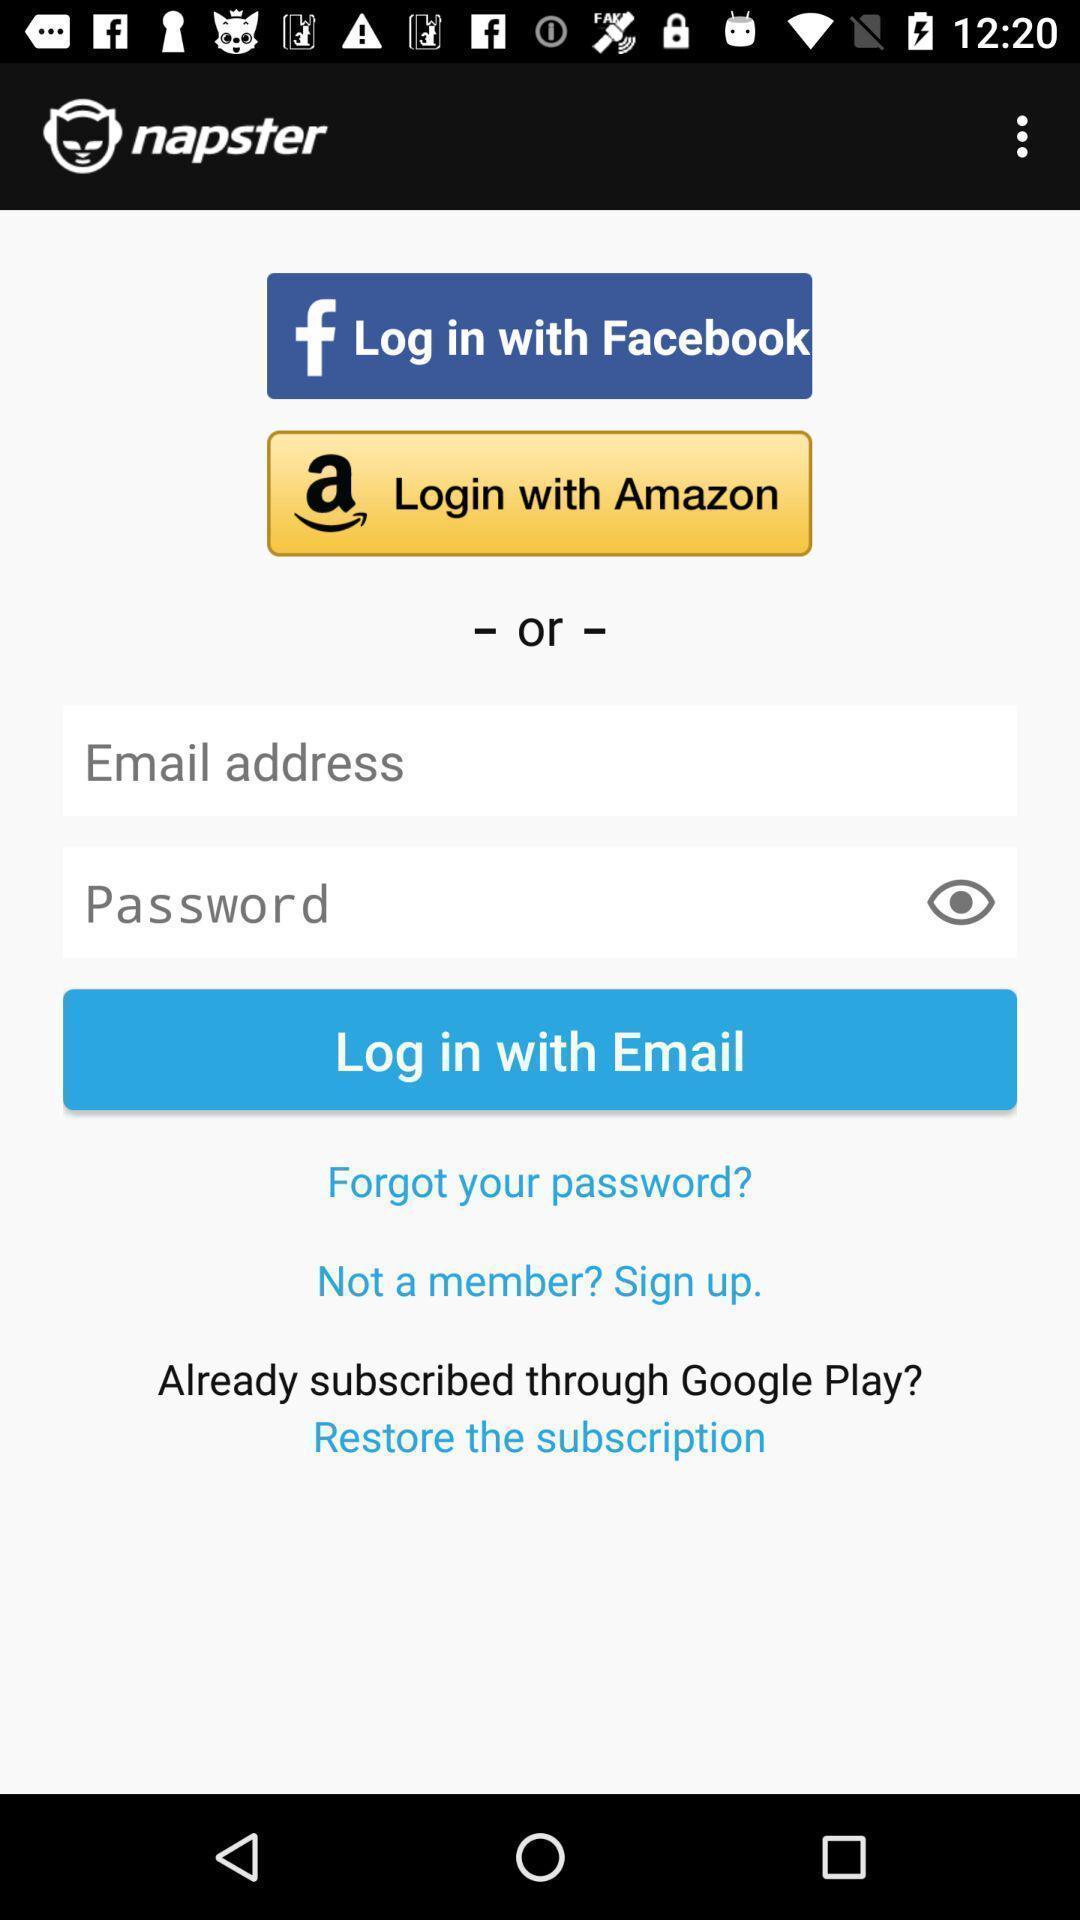Provide a description of this screenshot. Welcome to the login page. 